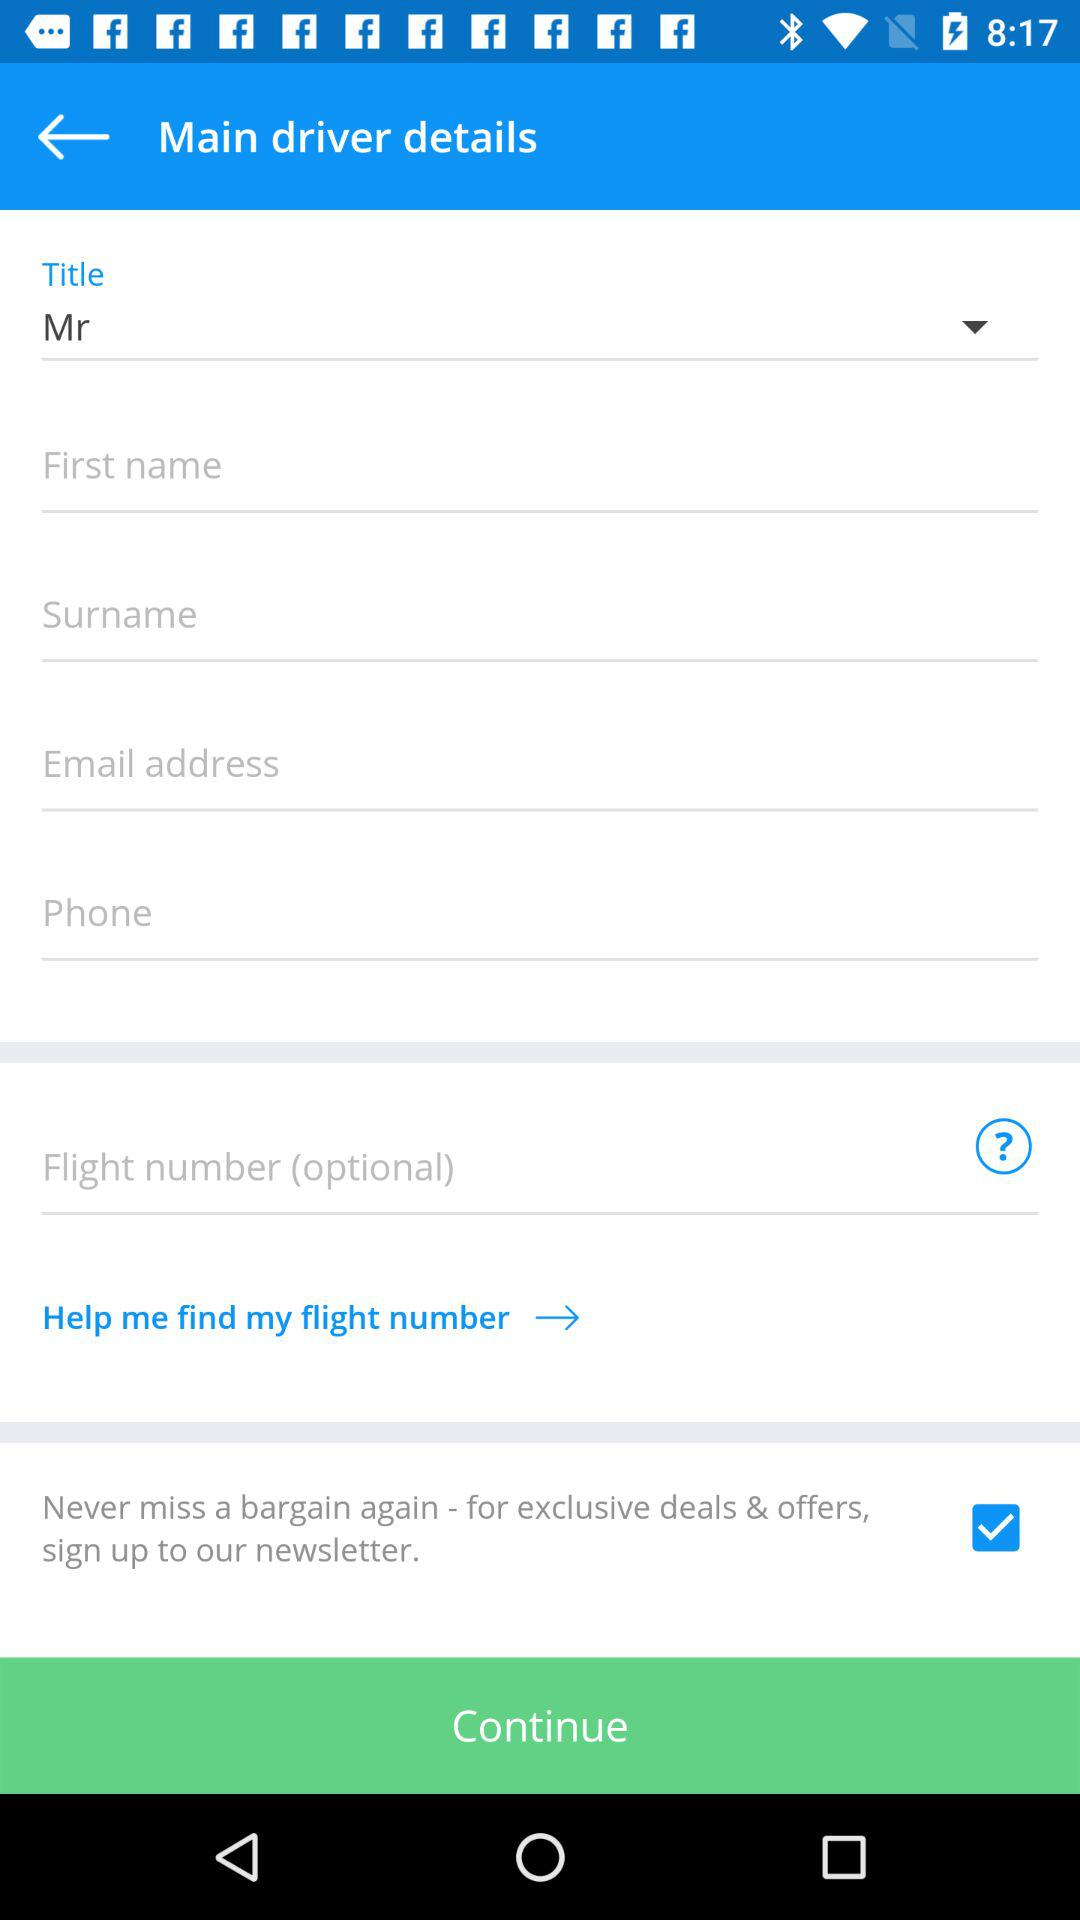What title is selected? The selected title is "Mr". 